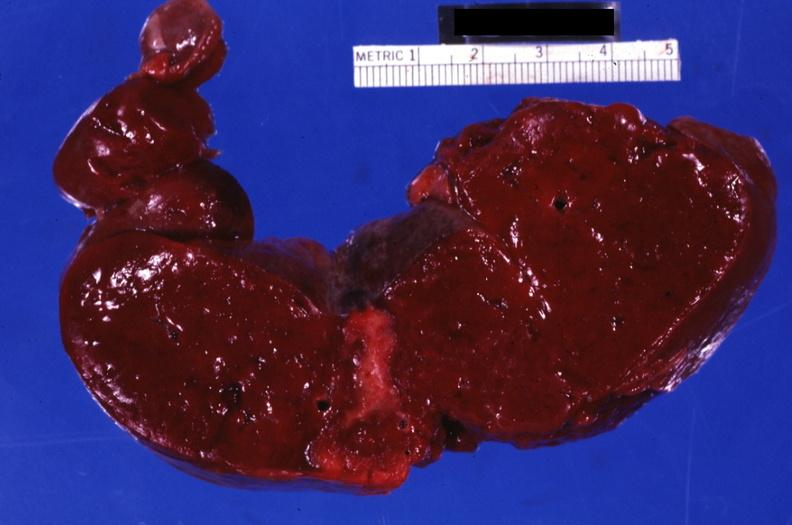what is present?
Answer the question using a single word or phrase. Hematologic 